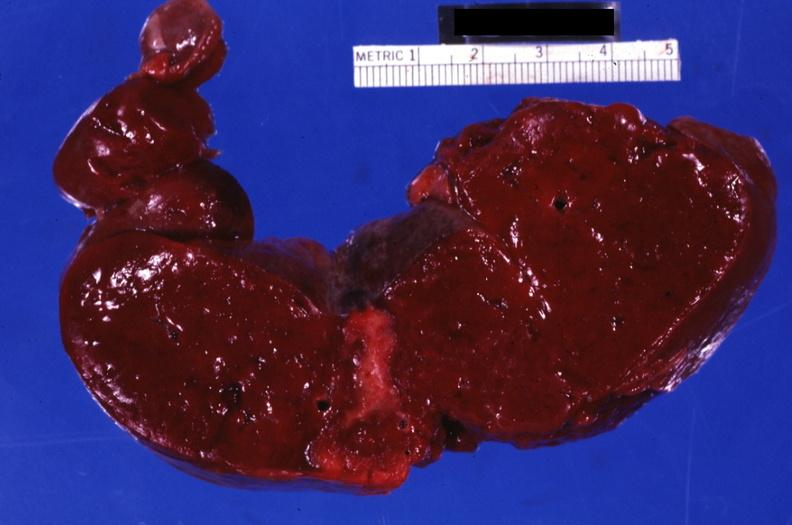what is present?
Answer the question using a single word or phrase. Hematologic 